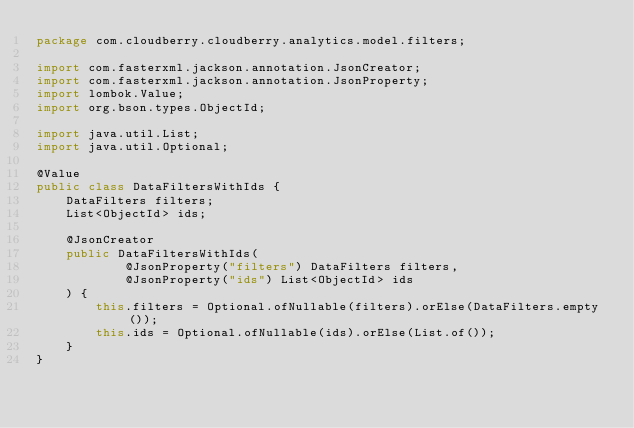<code> <loc_0><loc_0><loc_500><loc_500><_Java_>package com.cloudberry.cloudberry.analytics.model.filters;

import com.fasterxml.jackson.annotation.JsonCreator;
import com.fasterxml.jackson.annotation.JsonProperty;
import lombok.Value;
import org.bson.types.ObjectId;

import java.util.List;
import java.util.Optional;

@Value
public class DataFiltersWithIds {
    DataFilters filters;
    List<ObjectId> ids;

    @JsonCreator
    public DataFiltersWithIds(
            @JsonProperty("filters") DataFilters filters,
            @JsonProperty("ids") List<ObjectId> ids
    ) {
        this.filters = Optional.ofNullable(filters).orElse(DataFilters.empty());
        this.ids = Optional.ofNullable(ids).orElse(List.of());
    }
}
</code> 